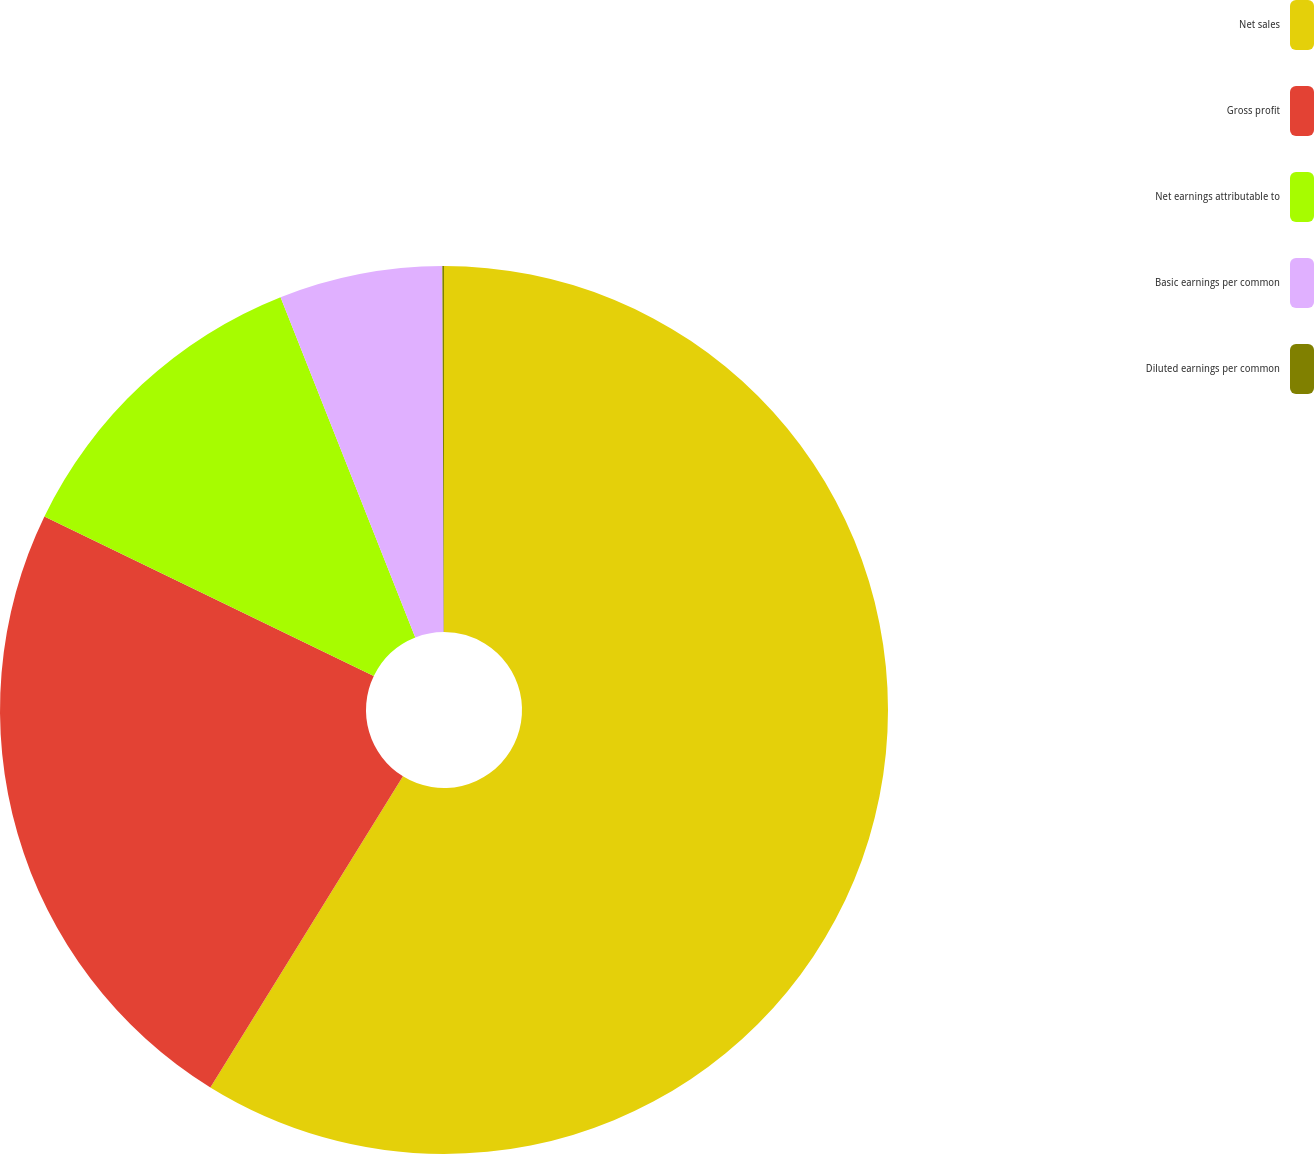Convert chart to OTSL. <chart><loc_0><loc_0><loc_500><loc_500><pie_chart><fcel>Net sales<fcel>Gross profit<fcel>Net earnings attributable to<fcel>Basic earnings per common<fcel>Diluted earnings per common<nl><fcel>58.82%<fcel>23.36%<fcel>11.82%<fcel>5.94%<fcel>0.06%<nl></chart> 